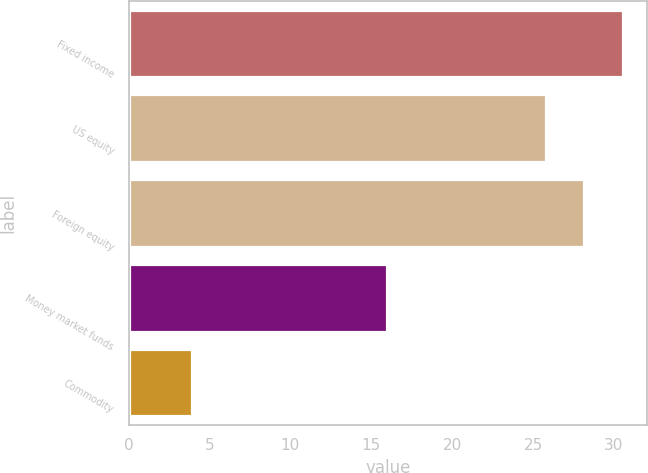Convert chart to OTSL. <chart><loc_0><loc_0><loc_500><loc_500><bar_chart><fcel>Fixed income<fcel>US equity<fcel>Foreign equity<fcel>Money market funds<fcel>Commodity<nl><fcel>30.54<fcel>25.8<fcel>28.17<fcel>16<fcel>3.9<nl></chart> 